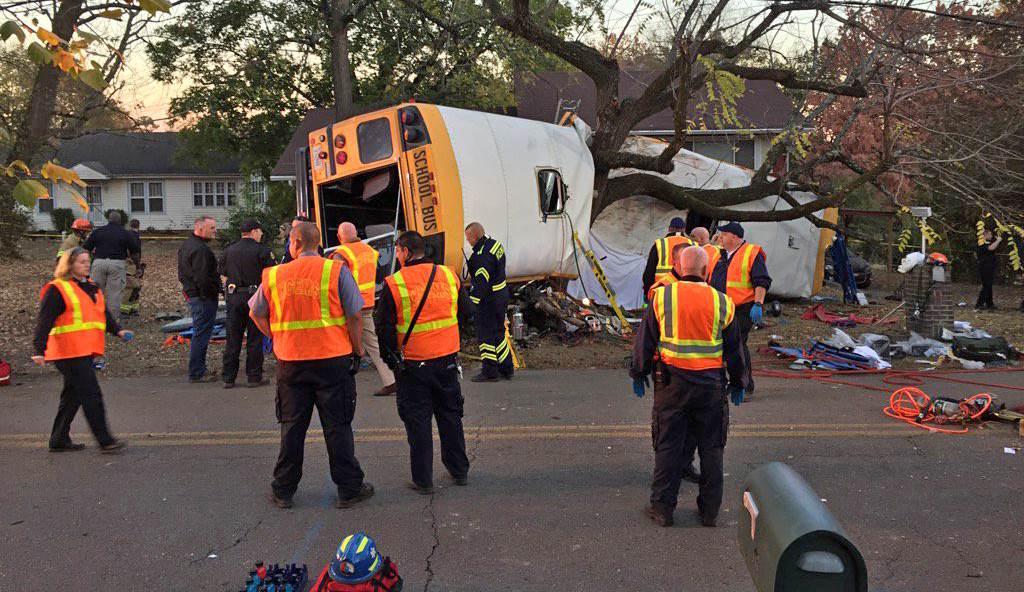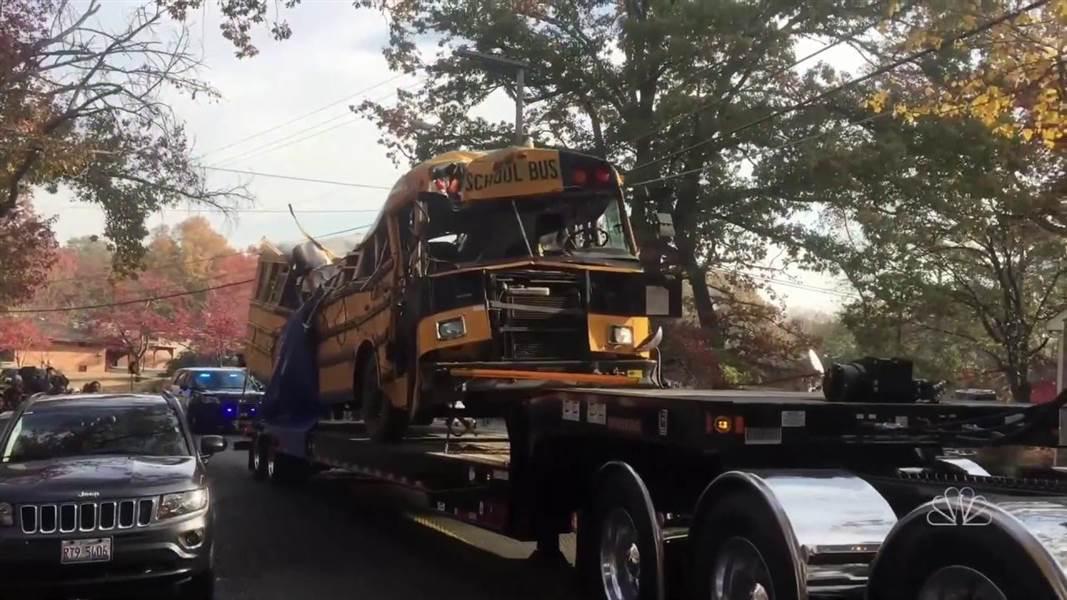The first image is the image on the left, the second image is the image on the right. Assess this claim about the two images: "The school bus door is open and ready to accept passengers.". Correct or not? Answer yes or no. No. The first image is the image on the left, the second image is the image on the right. Assess this claim about the two images: "Each image shows a yellow school bus which has been damaged in an accident.". Correct or not? Answer yes or no. Yes. 